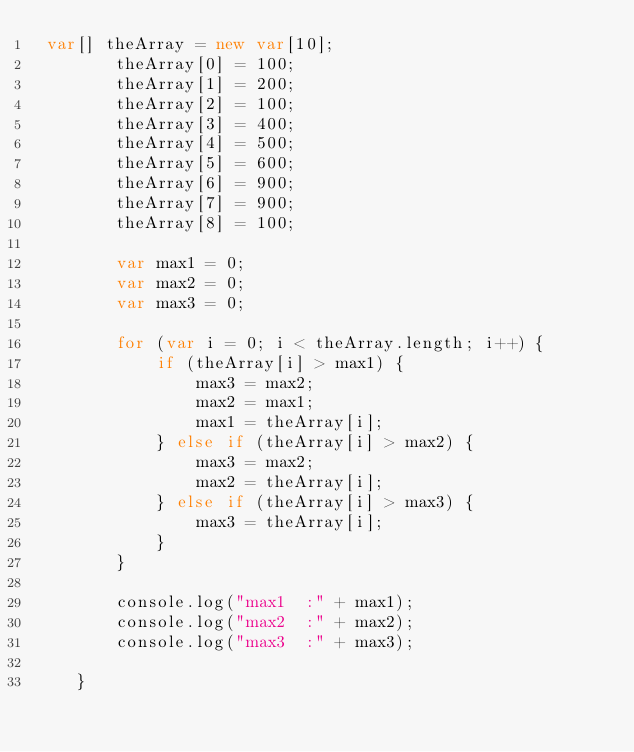<code> <loc_0><loc_0><loc_500><loc_500><_JavaScript_> var[] theArray = new var[10];
        theArray[0] = 100;
        theArray[1] = 200;
        theArray[2] = 100;
        theArray[3] = 400;
        theArray[4] = 500;
        theArray[5] = 600;
        theArray[6] = 900;
        theArray[7] = 900;
        theArray[8] = 100;

        var max1 = 0;
        var max2 = 0;
        var max3 = 0;

        for (var i = 0; i < theArray.length; i++) {
            if (theArray[i] > max1) {
                max3 = max2;
                max2 = max1;
                max1 = theArray[i];
            } else if (theArray[i] > max2) {
                max3 = max2;
                max2 = theArray[i];
            } else if (theArray[i] > max3) {
                max3 = theArray[i];
            }
        }

        console.log("max1  :" + max1);
        console.log("max2  :" + max2);
        console.log("max3  :" + max3);

    }</code> 